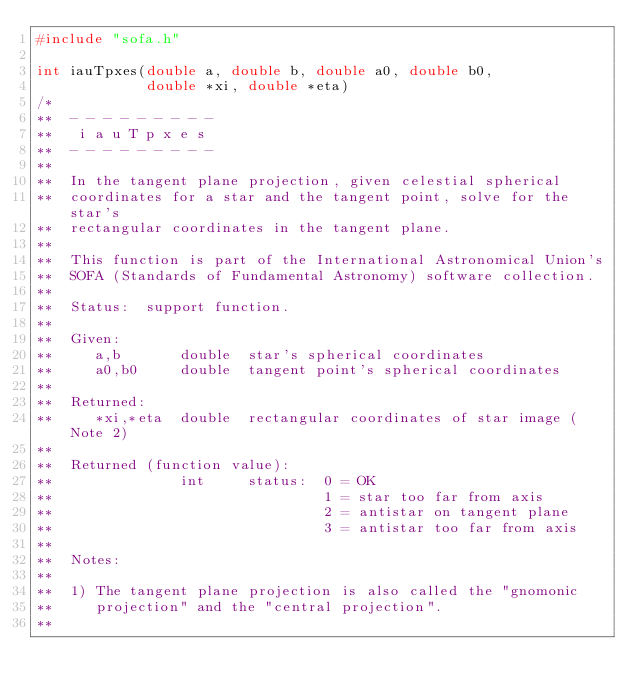<code> <loc_0><loc_0><loc_500><loc_500><_C_>#include "sofa.h"

int iauTpxes(double a, double b, double a0, double b0,
             double *xi, double *eta)
/*
**  - - - - - - - - -
**   i a u T p x e s
**  - - - - - - - - -
**
**  In the tangent plane projection, given celestial spherical
**  coordinates for a star and the tangent point, solve for the star's
**  rectangular coordinates in the tangent plane.
**
**  This function is part of the International Astronomical Union's
**  SOFA (Standards of Fundamental Astronomy) software collection.
**
**  Status:  support function.
**
**  Given:
**     a,b       double  star's spherical coordinates
**     a0,b0     double  tangent point's spherical coordinates
**
**  Returned:
**     *xi,*eta  double  rectangular coordinates of star image (Note 2)
**
**  Returned (function value):
**               int     status:  0 = OK
**                                1 = star too far from axis
**                                2 = antistar on tangent plane
**                                3 = antistar too far from axis
**
**  Notes:
**
**  1) The tangent plane projection is also called the "gnomonic
**     projection" and the "central projection".
**</code> 